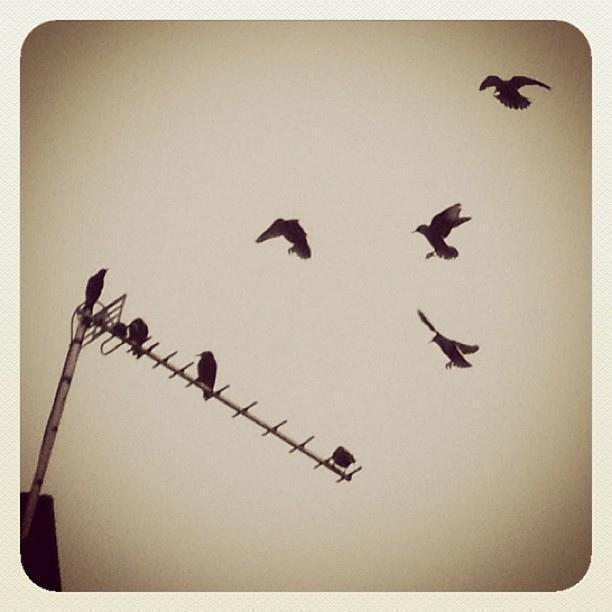How many birds are flying?
Give a very brief answer. 4. 